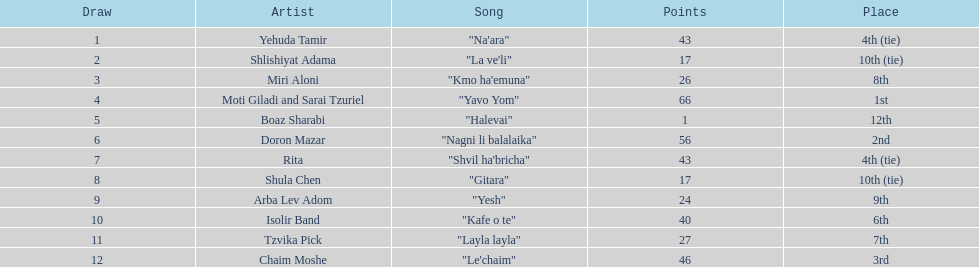Which artist had almost no points? Boaz Sharabi. 